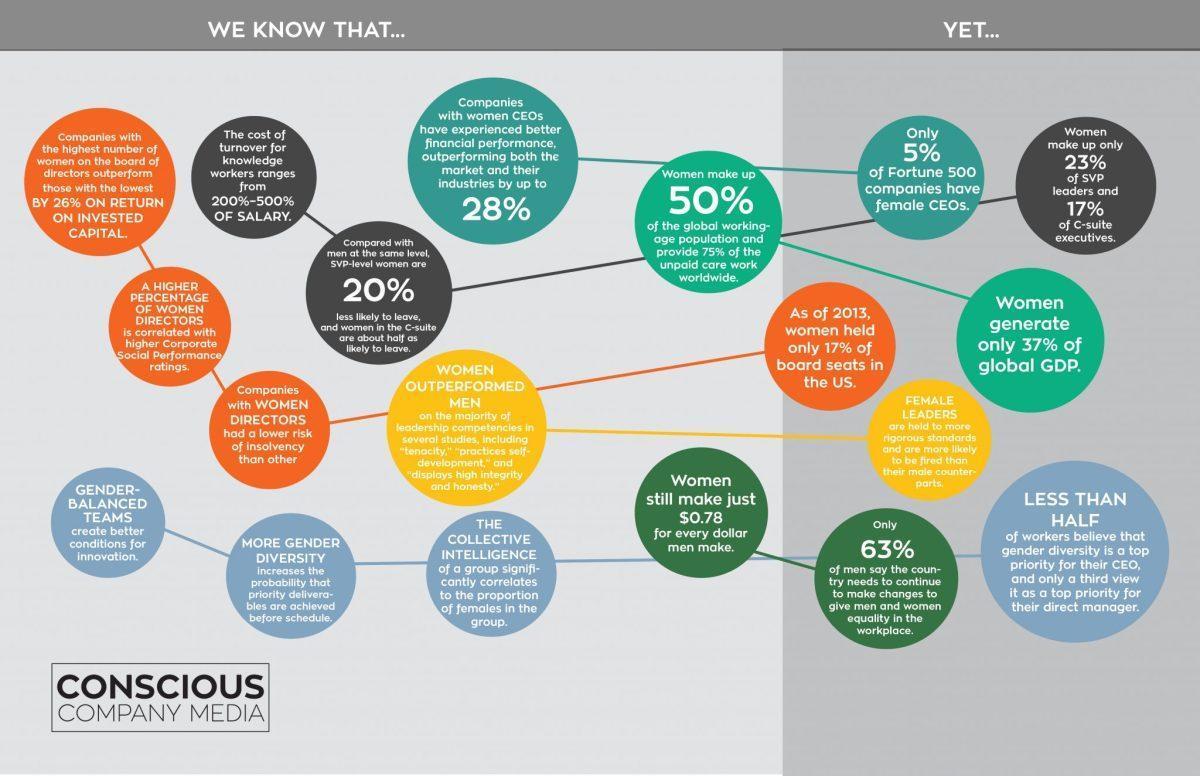What % of women in the C Suite are unlikely to leave
Answer the question with a short phrase. 50 Which companies have a lower risk of insolvency than others companies with women directors what creates better conditions for innovation gender-balanced teams How much of the global GDP do women generate 37% which sex is held to more rigorous standards and are more likely to be fired female What is correlated with higher corporate social performance ratings a higher percentage of women directors 